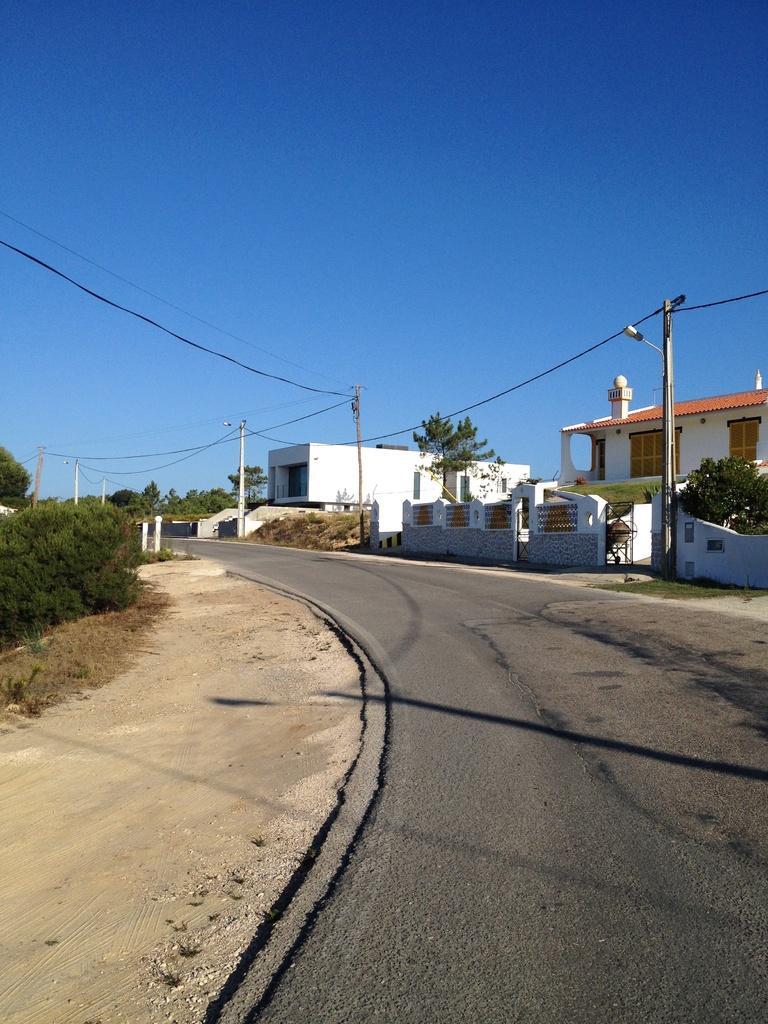Could you give a brief overview of what you see in this image? In the picture we can see a road, beside it, we can see a sand surface and bushes on it and on the other side of the road we can see some houses and poles with wires near it and in the background we can see some trees and sky. 